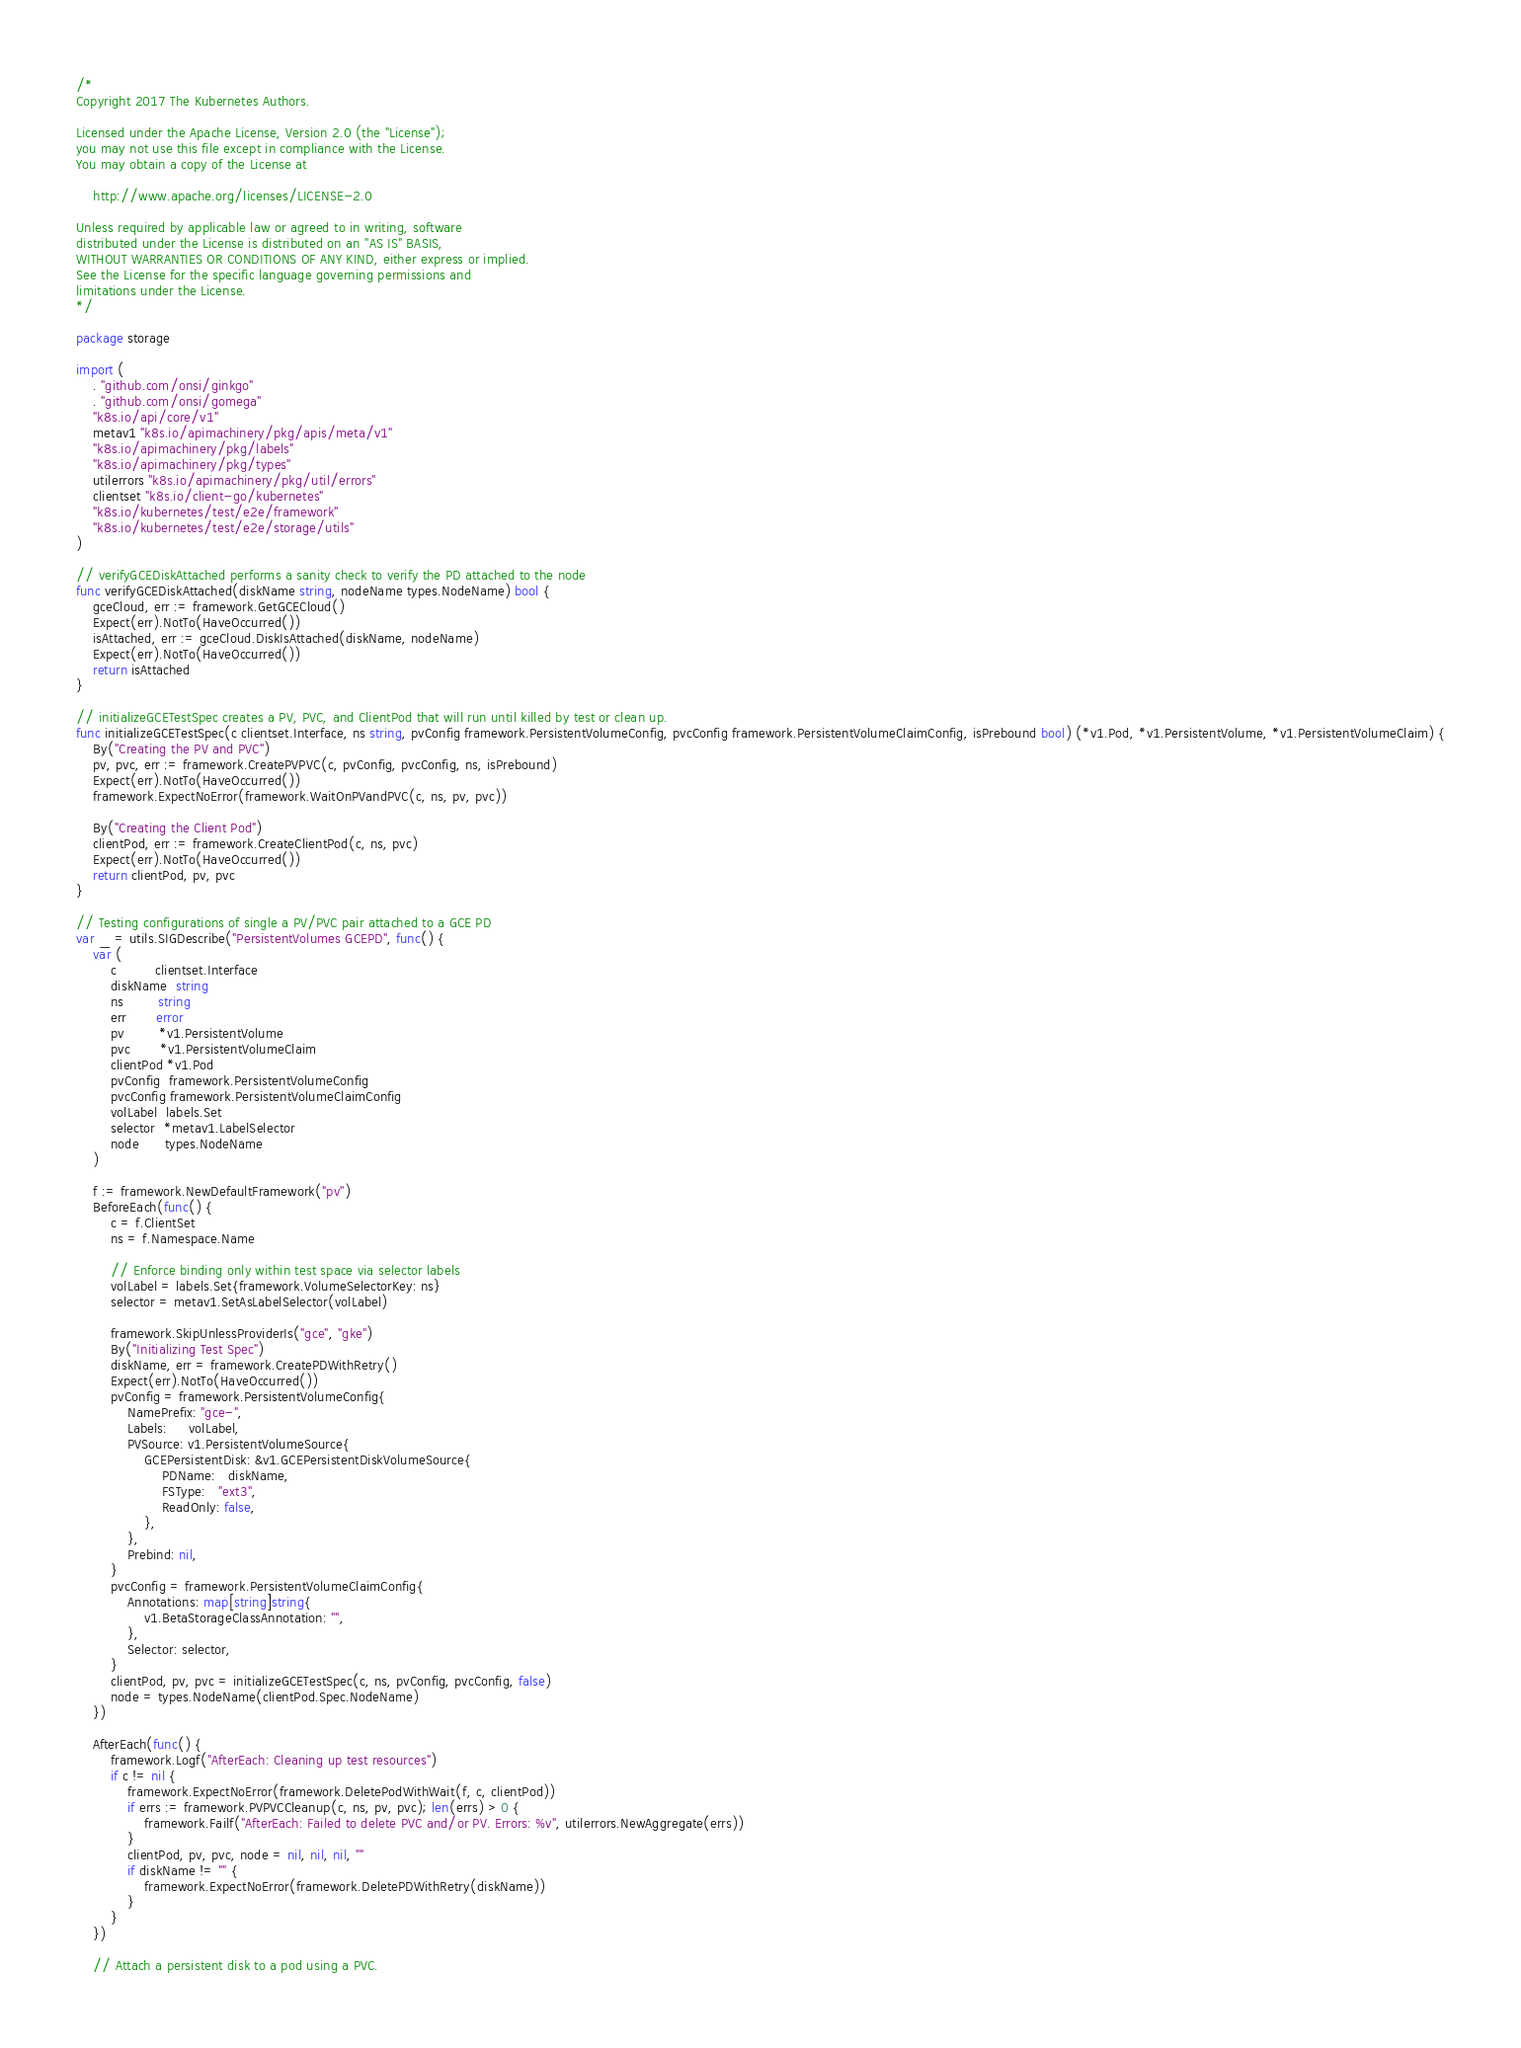Convert code to text. <code><loc_0><loc_0><loc_500><loc_500><_Go_>/*
Copyright 2017 The Kubernetes Authors.

Licensed under the Apache License, Version 2.0 (the "License");
you may not use this file except in compliance with the License.
You may obtain a copy of the License at

    http://www.apache.org/licenses/LICENSE-2.0

Unless required by applicable law or agreed to in writing, software
distributed under the License is distributed on an "AS IS" BASIS,
WITHOUT WARRANTIES OR CONDITIONS OF ANY KIND, either express or implied.
See the License for the specific language governing permissions and
limitations under the License.
*/

package storage

import (
	. "github.com/onsi/ginkgo"
	. "github.com/onsi/gomega"
	"k8s.io/api/core/v1"
	metav1 "k8s.io/apimachinery/pkg/apis/meta/v1"
	"k8s.io/apimachinery/pkg/labels"
	"k8s.io/apimachinery/pkg/types"
	utilerrors "k8s.io/apimachinery/pkg/util/errors"
	clientset "k8s.io/client-go/kubernetes"
	"k8s.io/kubernetes/test/e2e/framework"
	"k8s.io/kubernetes/test/e2e/storage/utils"
)

// verifyGCEDiskAttached performs a sanity check to verify the PD attached to the node
func verifyGCEDiskAttached(diskName string, nodeName types.NodeName) bool {
	gceCloud, err := framework.GetGCECloud()
	Expect(err).NotTo(HaveOccurred())
	isAttached, err := gceCloud.DiskIsAttached(diskName, nodeName)
	Expect(err).NotTo(HaveOccurred())
	return isAttached
}

// initializeGCETestSpec creates a PV, PVC, and ClientPod that will run until killed by test or clean up.
func initializeGCETestSpec(c clientset.Interface, ns string, pvConfig framework.PersistentVolumeConfig, pvcConfig framework.PersistentVolumeClaimConfig, isPrebound bool) (*v1.Pod, *v1.PersistentVolume, *v1.PersistentVolumeClaim) {
	By("Creating the PV and PVC")
	pv, pvc, err := framework.CreatePVPVC(c, pvConfig, pvcConfig, ns, isPrebound)
	Expect(err).NotTo(HaveOccurred())
	framework.ExpectNoError(framework.WaitOnPVandPVC(c, ns, pv, pvc))

	By("Creating the Client Pod")
	clientPod, err := framework.CreateClientPod(c, ns, pvc)
	Expect(err).NotTo(HaveOccurred())
	return clientPod, pv, pvc
}

// Testing configurations of single a PV/PVC pair attached to a GCE PD
var _ = utils.SIGDescribe("PersistentVolumes GCEPD", func() {
	var (
		c         clientset.Interface
		diskName  string
		ns        string
		err       error
		pv        *v1.PersistentVolume
		pvc       *v1.PersistentVolumeClaim
		clientPod *v1.Pod
		pvConfig  framework.PersistentVolumeConfig
		pvcConfig framework.PersistentVolumeClaimConfig
		volLabel  labels.Set
		selector  *metav1.LabelSelector
		node      types.NodeName
	)

	f := framework.NewDefaultFramework("pv")
	BeforeEach(func() {
		c = f.ClientSet
		ns = f.Namespace.Name

		// Enforce binding only within test space via selector labels
		volLabel = labels.Set{framework.VolumeSelectorKey: ns}
		selector = metav1.SetAsLabelSelector(volLabel)

		framework.SkipUnlessProviderIs("gce", "gke")
		By("Initializing Test Spec")
		diskName, err = framework.CreatePDWithRetry()
		Expect(err).NotTo(HaveOccurred())
		pvConfig = framework.PersistentVolumeConfig{
			NamePrefix: "gce-",
			Labels:     volLabel,
			PVSource: v1.PersistentVolumeSource{
				GCEPersistentDisk: &v1.GCEPersistentDiskVolumeSource{
					PDName:   diskName,
					FSType:   "ext3",
					ReadOnly: false,
				},
			},
			Prebind: nil,
		}
		pvcConfig = framework.PersistentVolumeClaimConfig{
			Annotations: map[string]string{
				v1.BetaStorageClassAnnotation: "",
			},
			Selector: selector,
		}
		clientPod, pv, pvc = initializeGCETestSpec(c, ns, pvConfig, pvcConfig, false)
		node = types.NodeName(clientPod.Spec.NodeName)
	})

	AfterEach(func() {
		framework.Logf("AfterEach: Cleaning up test resources")
		if c != nil {
			framework.ExpectNoError(framework.DeletePodWithWait(f, c, clientPod))
			if errs := framework.PVPVCCleanup(c, ns, pv, pvc); len(errs) > 0 {
				framework.Failf("AfterEach: Failed to delete PVC and/or PV. Errors: %v", utilerrors.NewAggregate(errs))
			}
			clientPod, pv, pvc, node = nil, nil, nil, ""
			if diskName != "" {
				framework.ExpectNoError(framework.DeletePDWithRetry(diskName))
			}
		}
	})

	// Attach a persistent disk to a pod using a PVC.</code> 